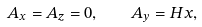Convert formula to latex. <formula><loc_0><loc_0><loc_500><loc_500>A _ { x } = A _ { z } = 0 , \quad A _ { y } = H x ,</formula> 